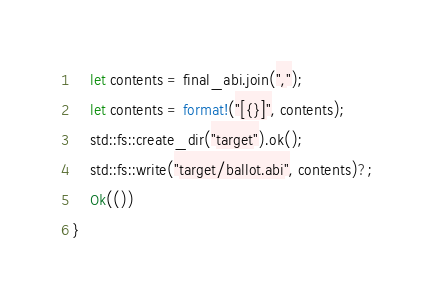<code> <loc_0><loc_0><loc_500><loc_500><_Rust_>    let contents = final_abi.join(",");
    let contents = format!("[{}]", contents);
    std::fs::create_dir("target").ok();
    std::fs::write("target/ballot.abi", contents)?;
    Ok(())
}
</code> 